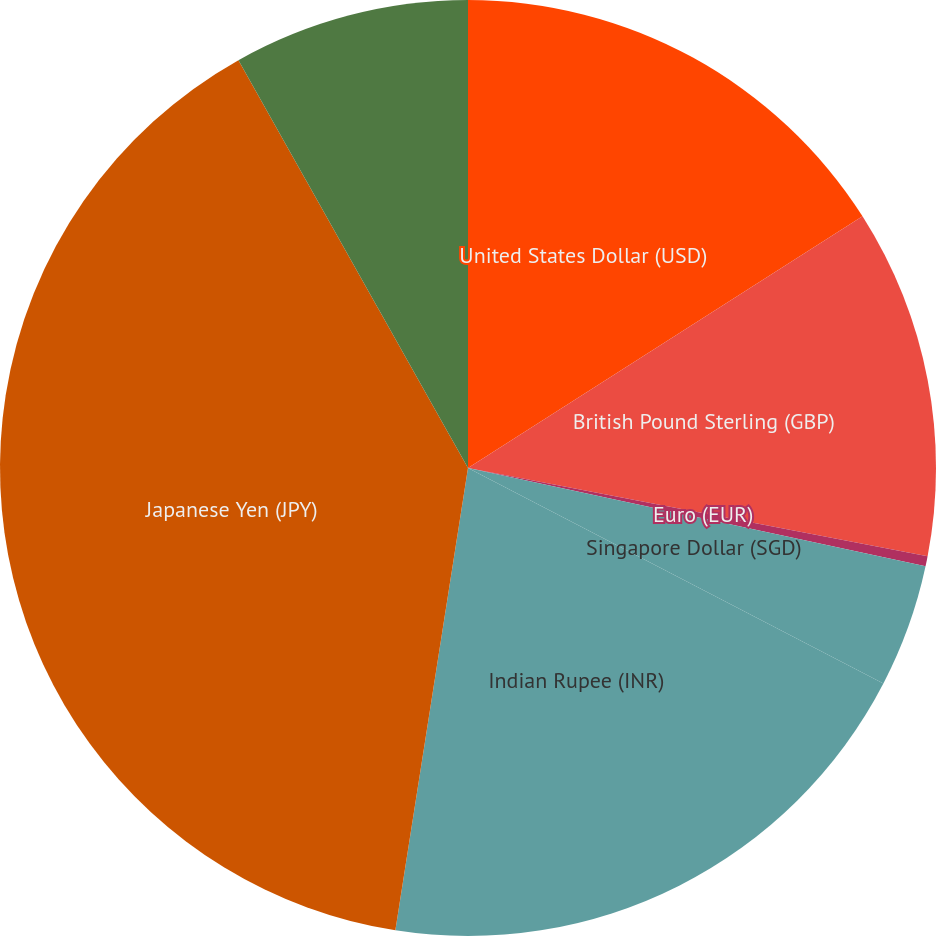Convert chart. <chart><loc_0><loc_0><loc_500><loc_500><pie_chart><fcel>United States Dollar (USD)<fcel>British Pound Sterling (GBP)<fcel>Euro (EUR)<fcel>Singapore Dollar (SGD)<fcel>Indian Rupee (INR)<fcel>Japanese Yen (JPY)<fcel>Romanian Leu (RON)<nl><fcel>15.96%<fcel>12.06%<fcel>0.35%<fcel>4.25%<fcel>19.86%<fcel>39.36%<fcel>8.16%<nl></chart> 